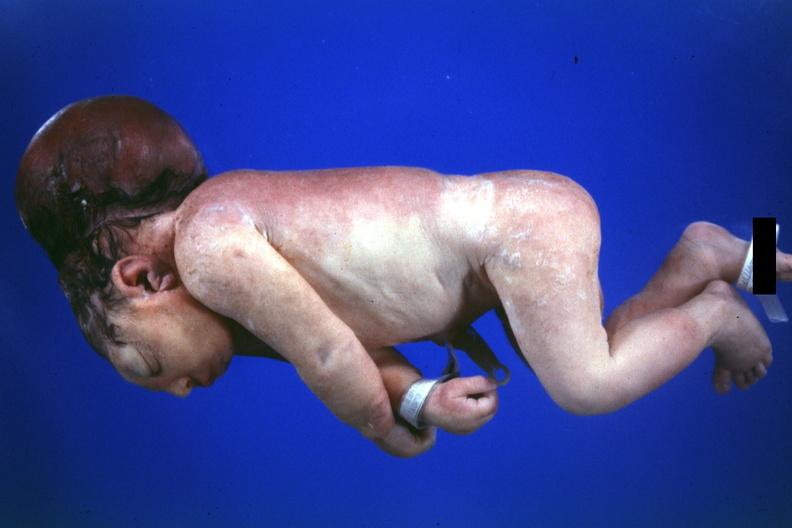what does this image show?
Answer the question using a single word or phrase. Dysraphism encephalocele occipital premature female no chromosomal defects lived one day 